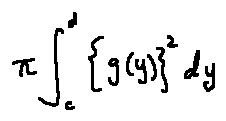<formula> <loc_0><loc_0><loc_500><loc_500>\pi \int \lim i t s _ { c } ^ { d } \{ g ( y ) \} ^ { 2 } d y</formula> 